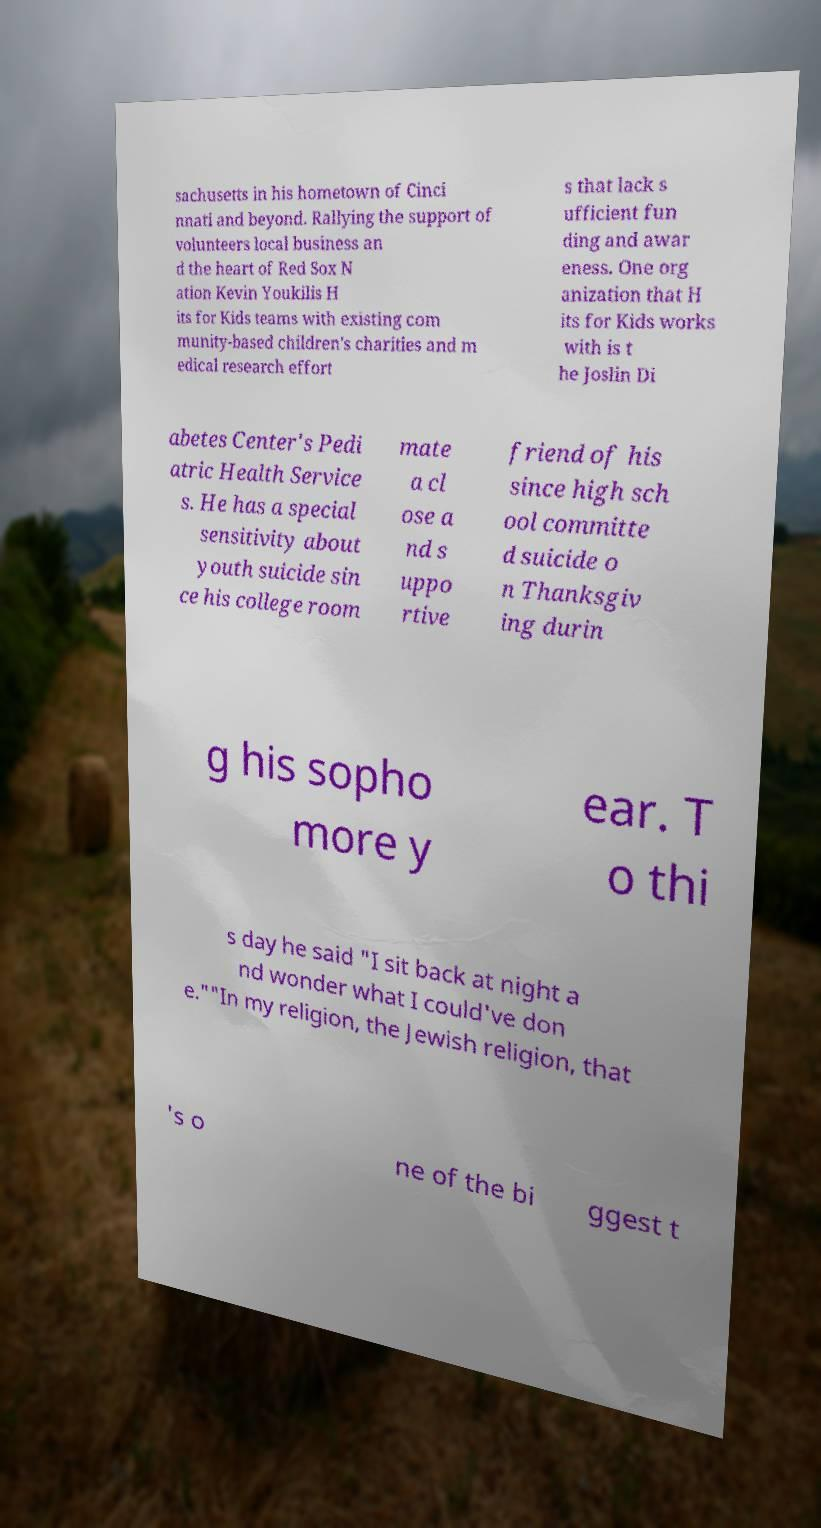Could you assist in decoding the text presented in this image and type it out clearly? sachusetts in his hometown of Cinci nnati and beyond. Rallying the support of volunteers local business an d the heart of Red Sox N ation Kevin Youkilis H its for Kids teams with existing com munity-based children's charities and m edical research effort s that lack s ufficient fun ding and awar eness. One org anization that H its for Kids works with is t he Joslin Di abetes Center's Pedi atric Health Service s. He has a special sensitivity about youth suicide sin ce his college room mate a cl ose a nd s uppo rtive friend of his since high sch ool committe d suicide o n Thanksgiv ing durin g his sopho more y ear. T o thi s day he said "I sit back at night a nd wonder what I could've don e.""In my religion, the Jewish religion, that 's o ne of the bi ggest t 